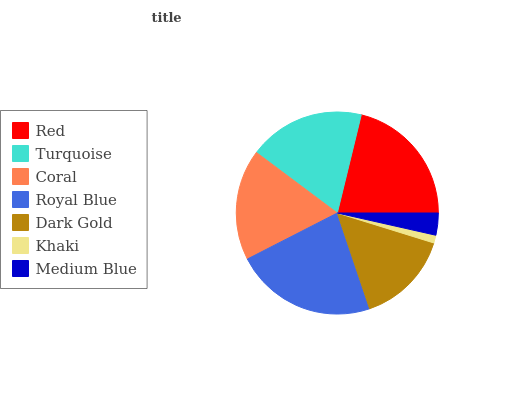Is Khaki the minimum?
Answer yes or no. Yes. Is Royal Blue the maximum?
Answer yes or no. Yes. Is Turquoise the minimum?
Answer yes or no. No. Is Turquoise the maximum?
Answer yes or no. No. Is Red greater than Turquoise?
Answer yes or no. Yes. Is Turquoise less than Red?
Answer yes or no. Yes. Is Turquoise greater than Red?
Answer yes or no. No. Is Red less than Turquoise?
Answer yes or no. No. Is Coral the high median?
Answer yes or no. Yes. Is Coral the low median?
Answer yes or no. Yes. Is Dark Gold the high median?
Answer yes or no. No. Is Royal Blue the low median?
Answer yes or no. No. 